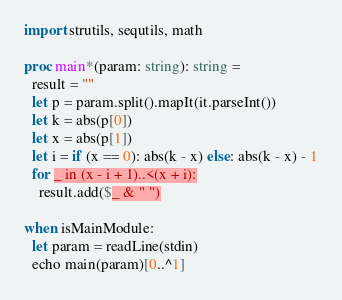Convert code to text. <code><loc_0><loc_0><loc_500><loc_500><_Nim_>import strutils, sequtils, math

proc main*(param: string): string = 
  result = ""
  let p = param.split().mapIt(it.parseInt())
  let k = abs(p[0])
  let x = abs(p[1])
  let i = if (x == 0): abs(k - x) else: abs(k - x) - 1
  for _ in (x - i + 1)..<(x + i):
    result.add($_ & " ")

when isMainModule:
  let param = readLine(stdin)
  echo main(param)[0..^1]</code> 